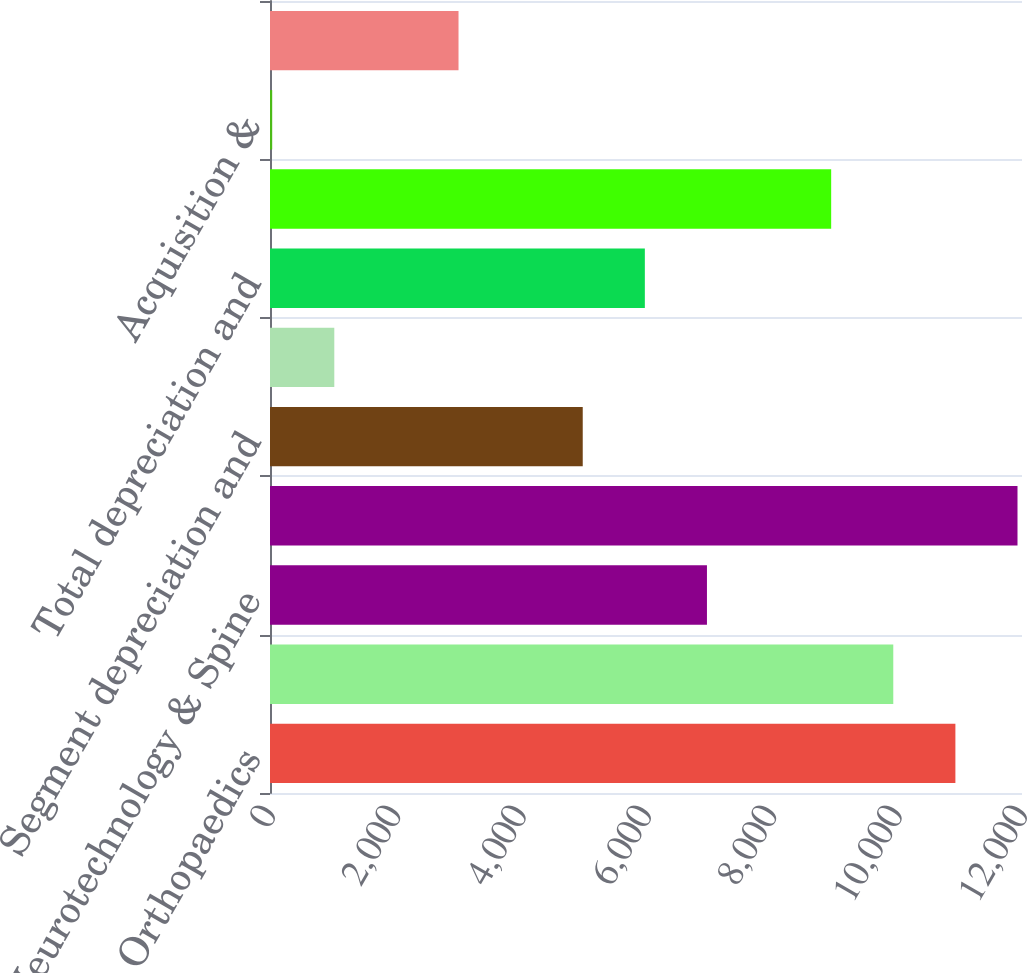<chart> <loc_0><loc_0><loc_500><loc_500><bar_chart><fcel>Orthopaedics<fcel>MedSurg<fcel>Neurotechnology & Spine<fcel>Net sales<fcel>Segment depreciation and<fcel>Corporate and Other<fcel>Total depreciation and<fcel>Segment operating income<fcel>Acquisition &<fcel>Amortization of intangible<nl><fcel>10937.1<fcel>9946<fcel>6972.7<fcel>11928.2<fcel>4990.5<fcel>1026.1<fcel>5981.6<fcel>8954.9<fcel>35<fcel>3008.3<nl></chart> 